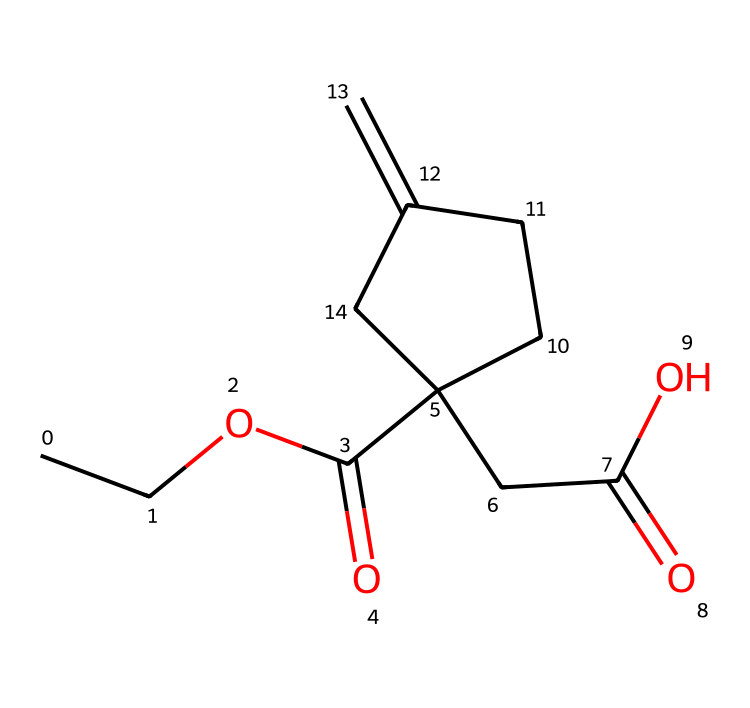What is the main functional group in this molecule? The chemical structure contains a carboxyl group (-COOH) as indicated by the carbon atom double bonded to oxygen and single bonded to hydroxyl (OH).
Answer: carboxyl How many carbon atoms are present in the structure? By counting the carbon atoms in the SMILES representation, there are 10 carbon atoms in total present in the entire structure.
Answer: 10 What type of isomerism might this compound exhibit? The presence of a double bond (C=C) suggests potential geometric isomerism (cis/trans) due to the limited rotation around the double bond.
Answer: geometric isomerism Is this compound likely to be soluble in water? The presence of both a carboxyl group and a hydroxyl group suggests that this compound can form hydrogen bonds with water, thereby enhancing its solubility.
Answer: likely Which part of the structure indicates it is a growth regulator? The presence of the specific functional groups alongside the branched structure typically signifies activity related to plant growth regulation, as seen in similar compounds.
Answer: functional groups What type of chemical category does this molecule belong to? Given its properties and structure, this molecule is classified as an organometallic compound due to the presence and configuration around its carbon framework which affects its interaction with metals in the soil.
Answer: organometallic 